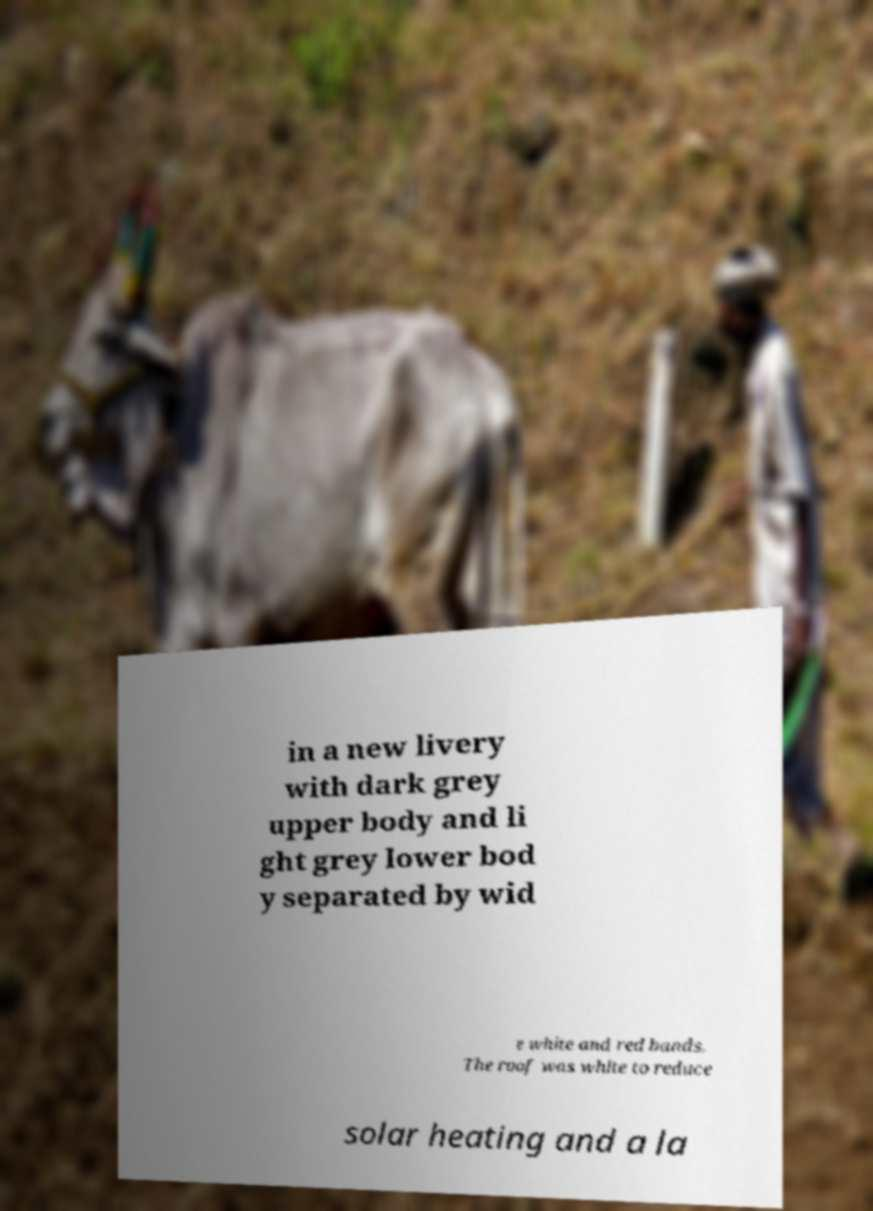Could you extract and type out the text from this image? in a new livery with dark grey upper body and li ght grey lower bod y separated by wid e white and red bands. The roof was white to reduce solar heating and a la 